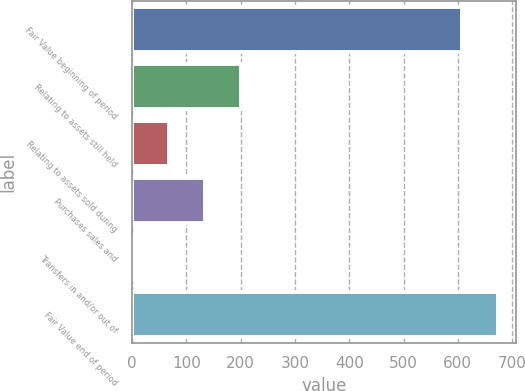Convert chart. <chart><loc_0><loc_0><loc_500><loc_500><bar_chart><fcel>Fair Value beginning of period<fcel>Relating to assets still held<fcel>Relating to assets sold during<fcel>Purchases sales and<fcel>Transfers in and/or out of<fcel>Fair Value end of period<nl><fcel>607<fcel>201.02<fcel>68.18<fcel>134.6<fcel>1.76<fcel>673.42<nl></chart> 